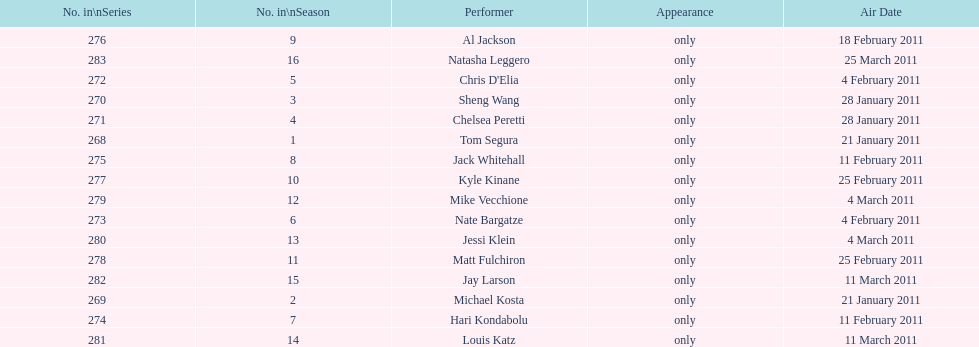What was the number of performers who appeared on january 21, 2011's air date? 2. 